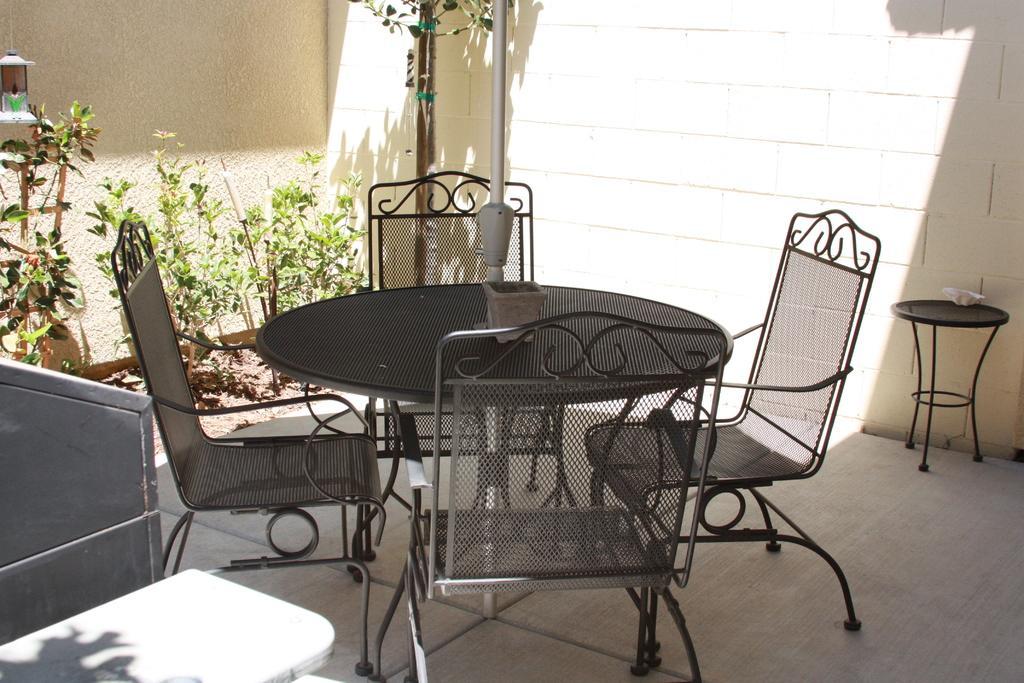How would you summarize this image in a sentence or two? On the left side of the image there is a wall and some object. In the center of the image we can see one table and chairs. On the table, we can see some objects. In the background there is a wall, plants, one stool and a few other objects. 